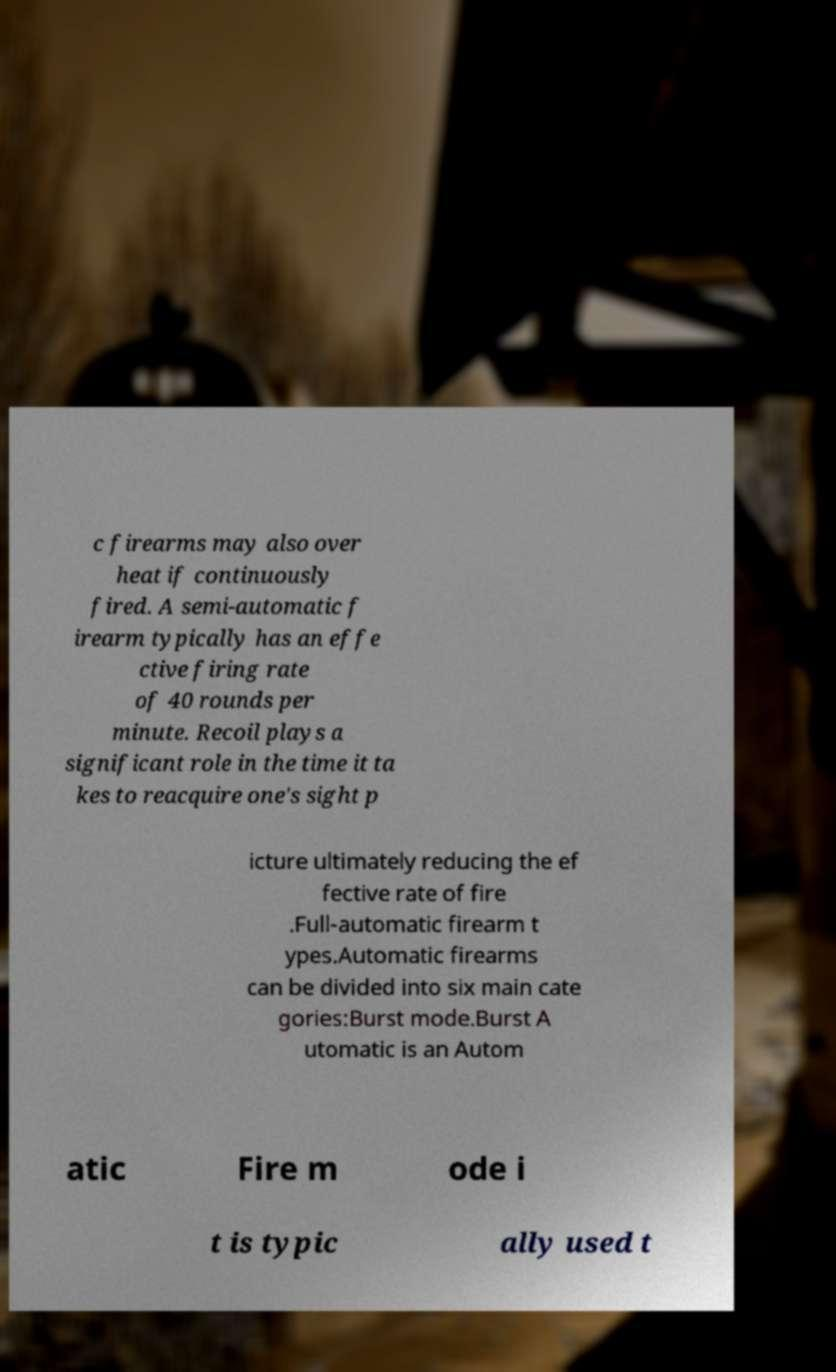There's text embedded in this image that I need extracted. Can you transcribe it verbatim? c firearms may also over heat if continuously fired. A semi-automatic f irearm typically has an effe ctive firing rate of 40 rounds per minute. Recoil plays a significant role in the time it ta kes to reacquire one's sight p icture ultimately reducing the ef fective rate of fire .Full-automatic firearm t ypes.Automatic firearms can be divided into six main cate gories:Burst mode.Burst A utomatic is an Autom atic Fire m ode i t is typic ally used t 